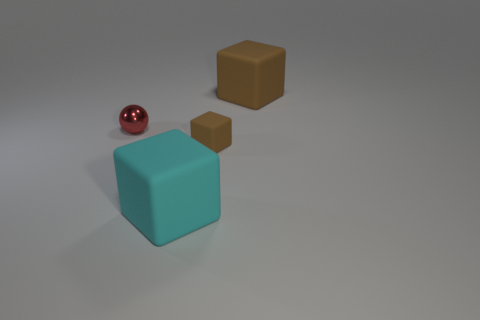Subtract all big brown blocks. How many blocks are left? 2 Add 4 tiny red metal things. How many objects exist? 8 Subtract all blue balls. How many gray cubes are left? 0 Subtract all cyan cubes. How many cubes are left? 2 Subtract 1 spheres. How many spheres are left? 0 Subtract all spheres. How many objects are left? 3 Subtract all green blocks. Subtract all cyan balls. How many blocks are left? 3 Subtract all big cyan objects. Subtract all large metallic cubes. How many objects are left? 3 Add 4 brown cubes. How many brown cubes are left? 6 Add 1 big cyan matte blocks. How many big cyan matte blocks exist? 2 